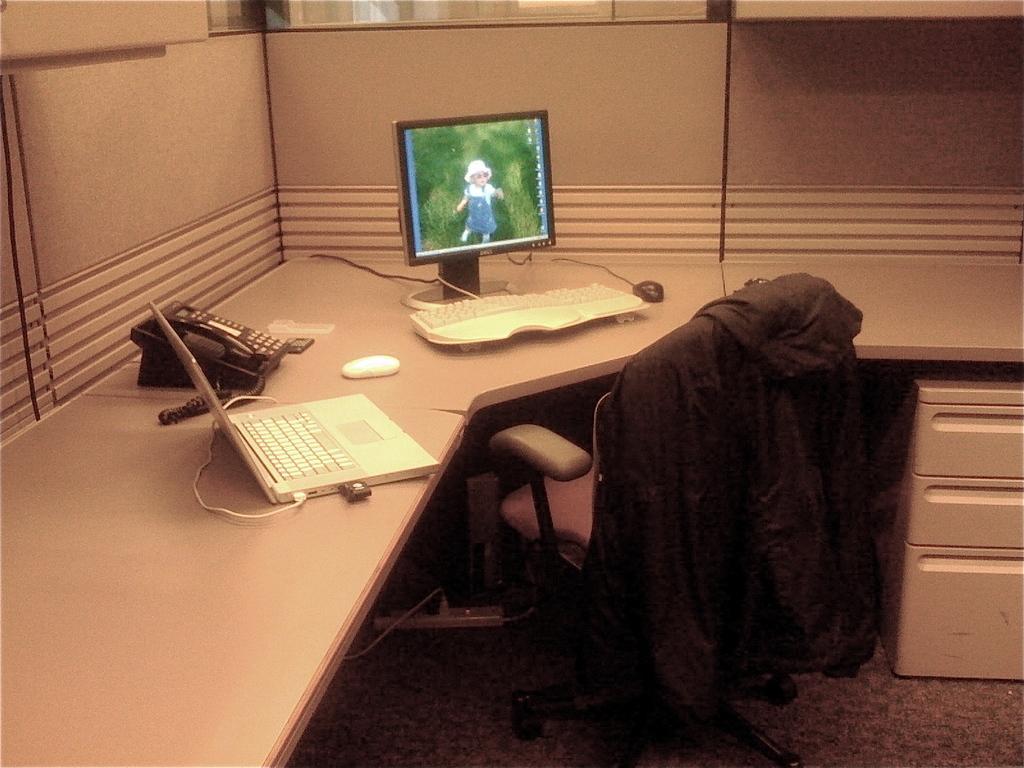Please provide a concise description of this image. This image is taken inside a room. In this image there is a table and a chair with a desk, on the table there is a keyboard, mouse, monitor, laptop and a telephone were there. At the bottom of the image there is a floor with mat. 